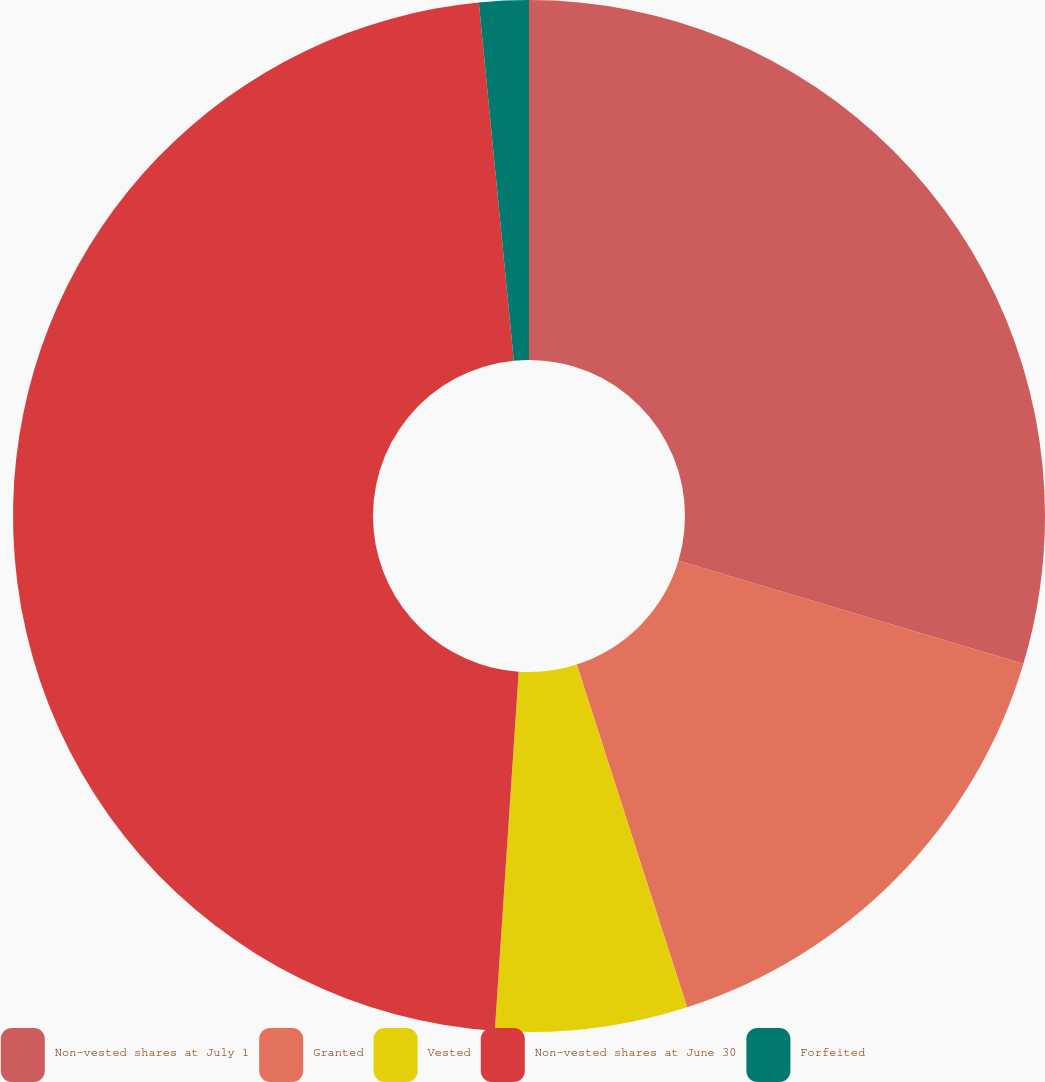<chart> <loc_0><loc_0><loc_500><loc_500><pie_chart><fcel>Non-vested shares at July 1<fcel>Granted<fcel>Vested<fcel>Non-vested shares at June 30<fcel>Forfeited<nl><fcel>29.62%<fcel>15.42%<fcel>6.01%<fcel>47.39%<fcel>1.55%<nl></chart> 